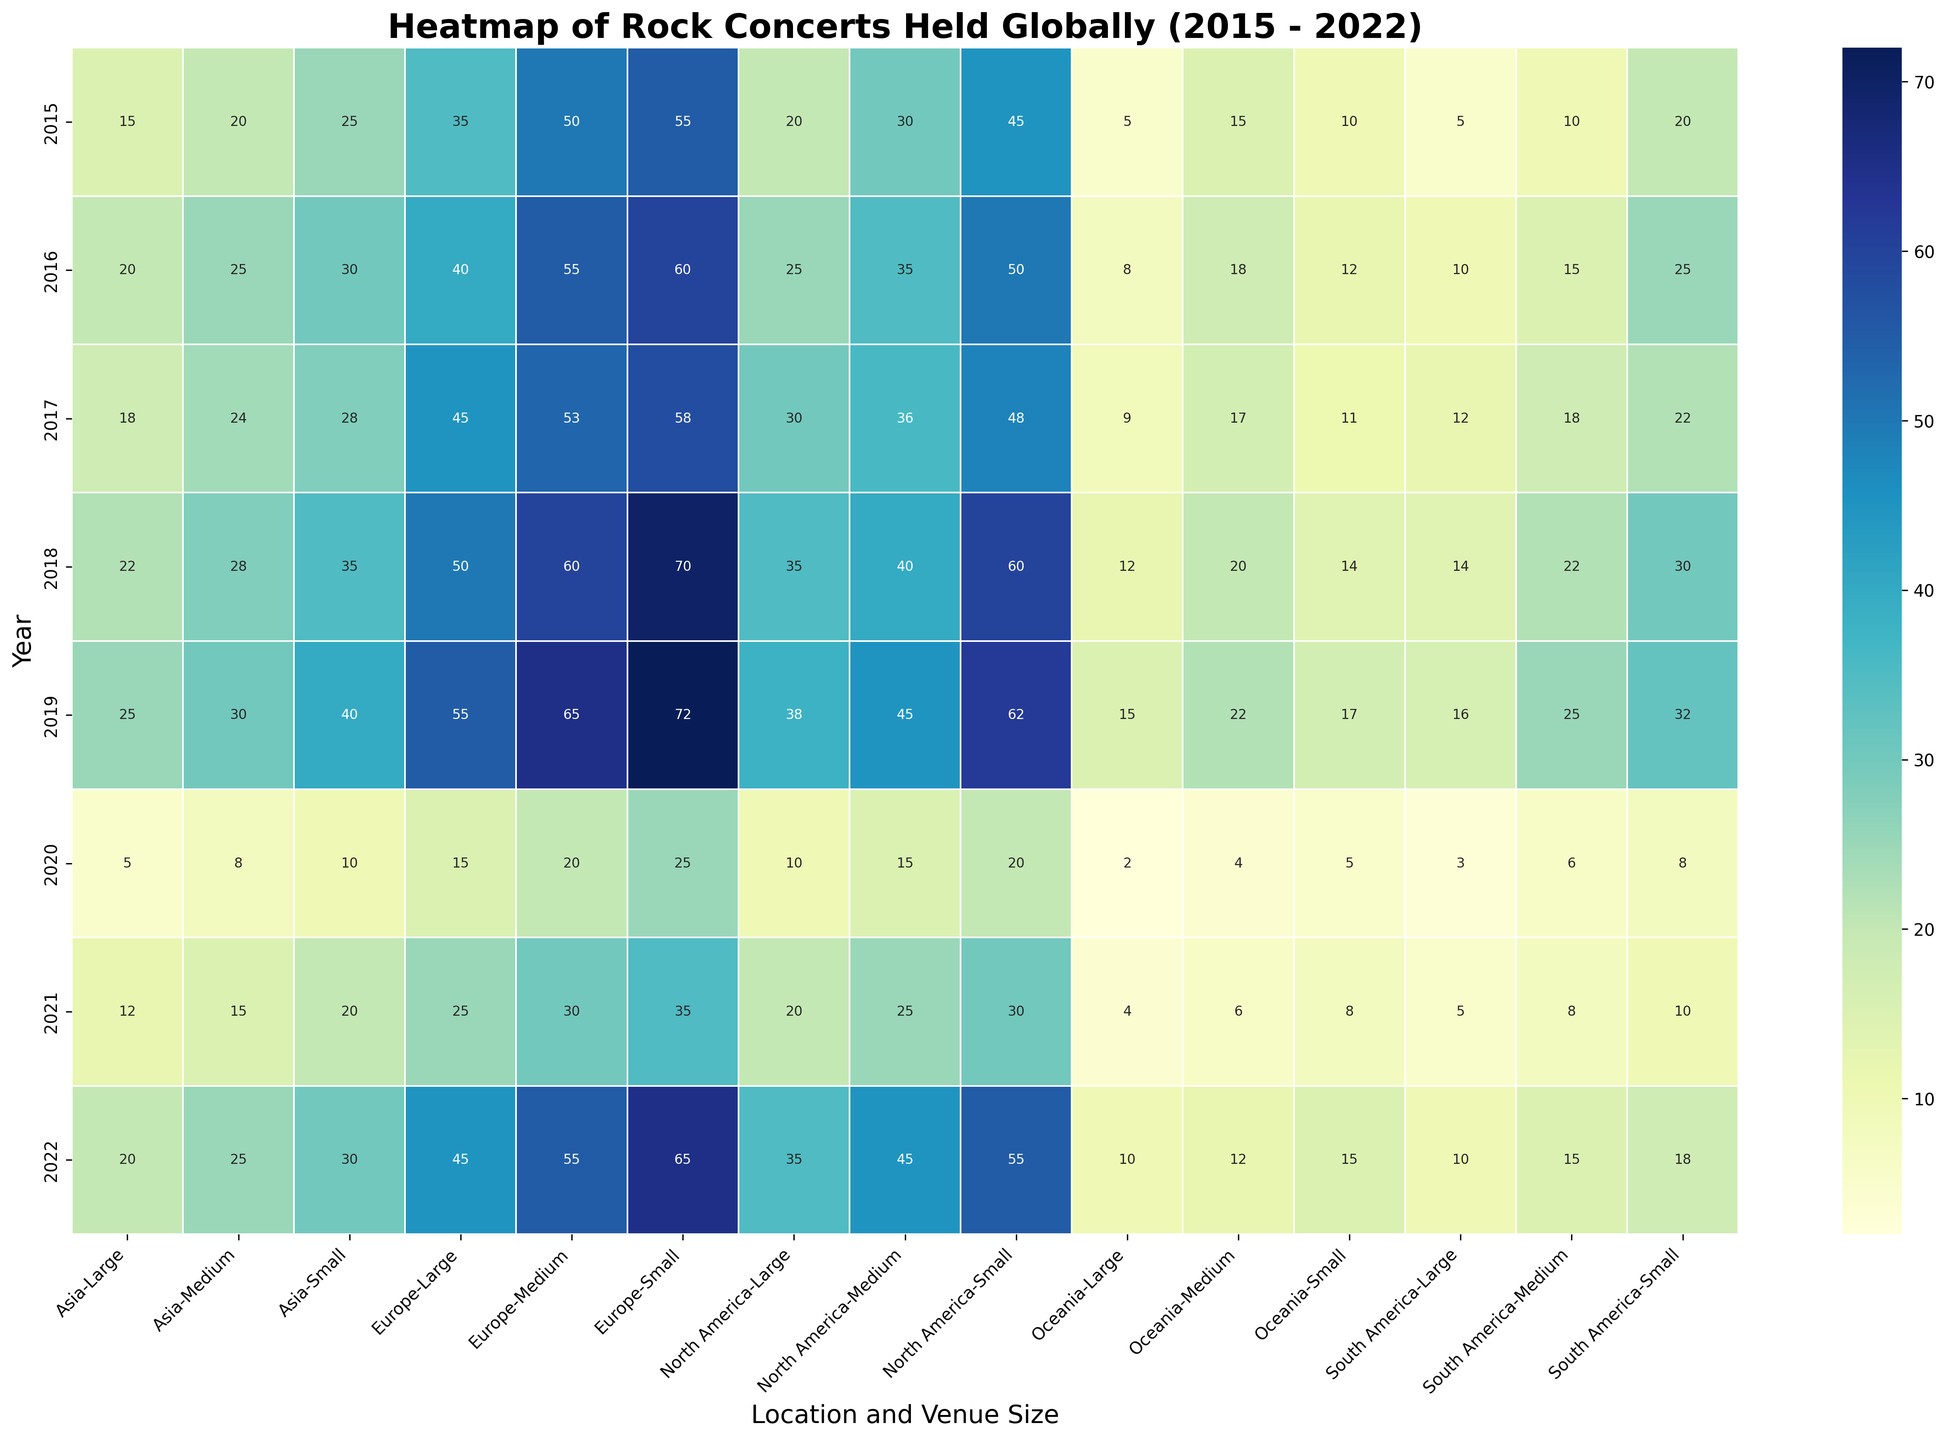Which year had the highest number of small venue concerts in Europe? Look at the Europe column under the Small venue size section and compare the values across all years. The highest value in this column represents the year with the highest number of small venue concerts.
Answer: 2019 Which location had the least number of large venue concerts in 2020? Check the 2020 row and compare the data in the Large venue size column across all locations. Identify the lowest value to determine which location had the least number of large venue concerts.
Answer: Oceania By how much did the number of medium venue concerts in North America decrease from 2019 to 2020? Find the number of medium venue concerts in North America for both 2019 and 2020. Subtract the 2020 value from the 2019 value to get the decrease.
Answer: 30 What's the total number of concerts held in Asia in 2018? Add up the number of concerts held in small, medium, and large venues in Asia for 2018. This is the sum of the numbers in Asia's Small, Medium, and Large columns for 2018.
Answer: 85 In which year did South America have the highest number of total concerts? Sum up the small, medium, and large venue concerts for South America across all years and compare the totals to identify the highest one.
Answer: 2019 Which venue size consistently had the most concerts across all years in North America? For each year, sum the number of concerts for each venue size in North America and compare them. Check which venue size consistently had the highest sum.
Answer: Small What is the difference in the number of small venue concerts in Oceania between the years 2019 and 2021? Look at the number of small venue concerts in Oceania for 2019 and 2021. Subtract the 2021 value from the 2019 value to find the difference.
Answer: 9 Which year had the sharpest decline in total number of concerts globally compared to the previous year? For each year, sum the number of concerts across all locations and venue sizes, then find the year with the largest decrease compared to the previous year's total.
Answer: 2020 